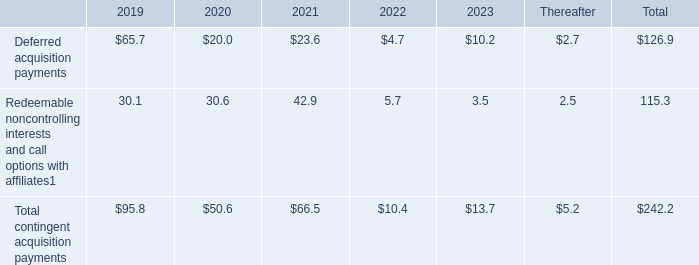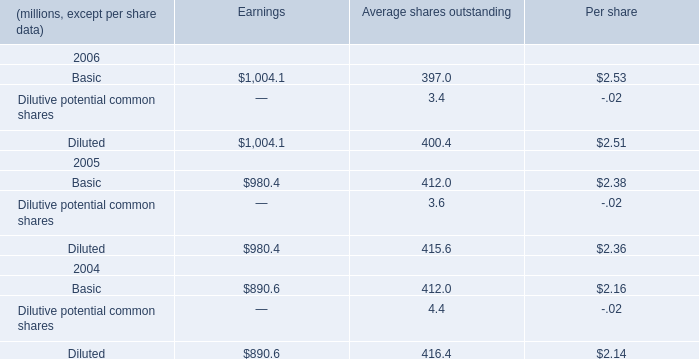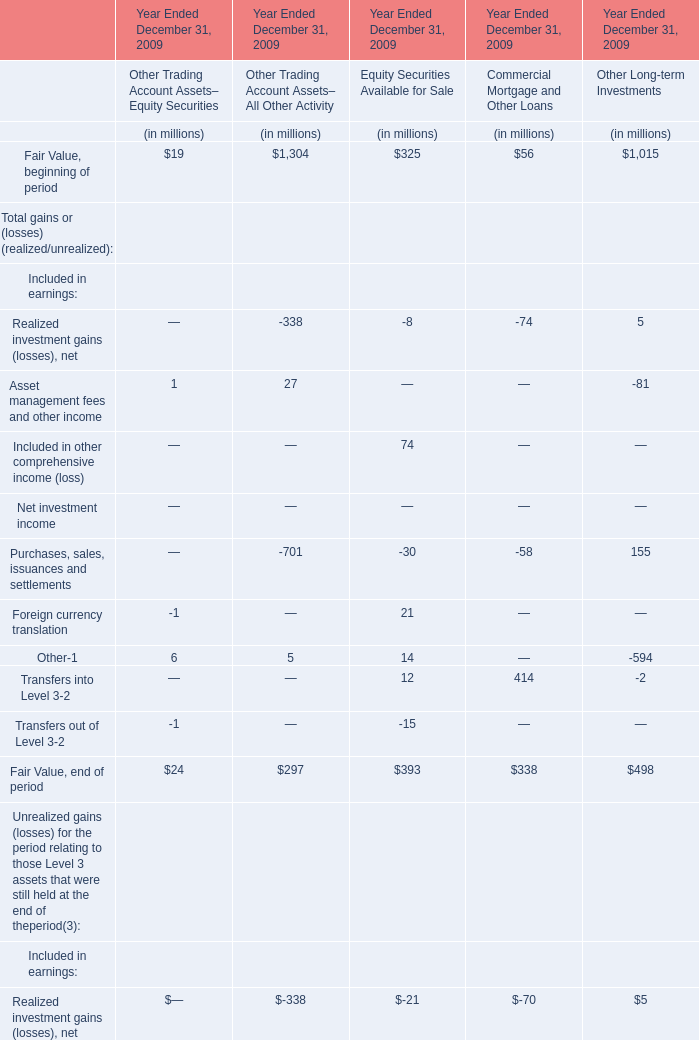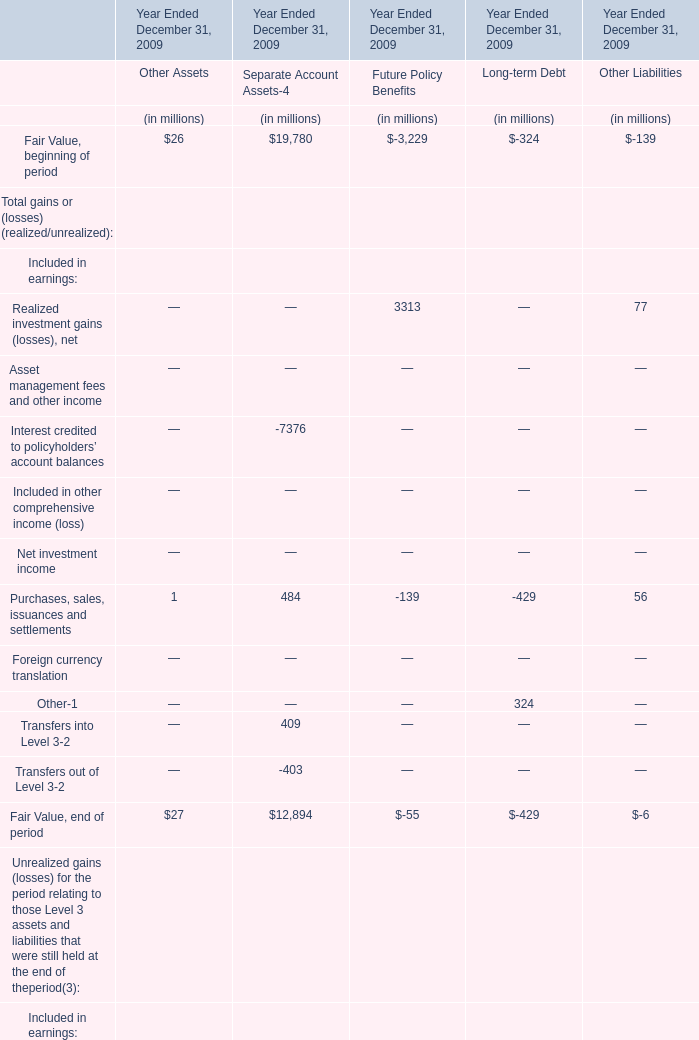what was the percent decrease of redeemable noncontrolling interests and call options with affiliates from 2021 to 2022? 
Computations: (((42.9 - 5.7) / 42.9) * 100)
Answer: 86.71329. 